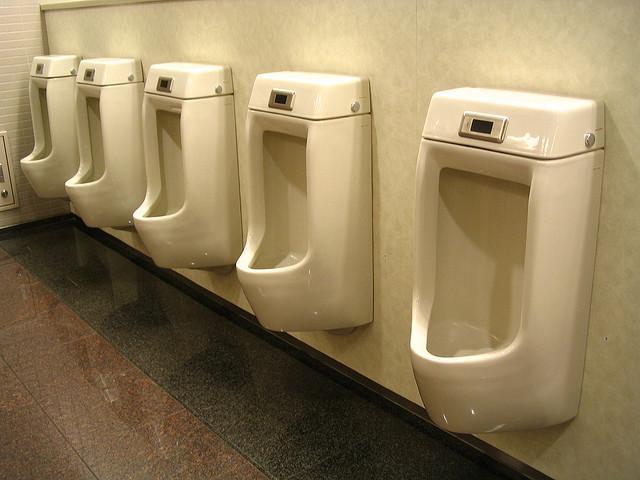How many toilets are there?
Give a very brief answer. 5. 